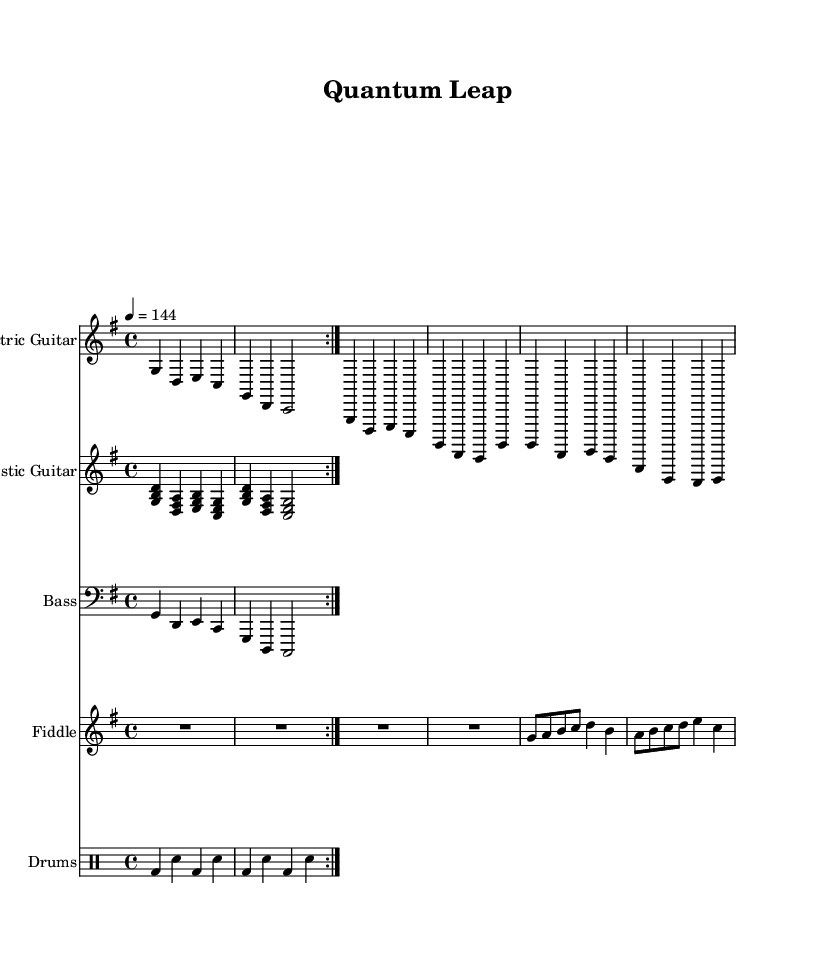What is the key signature of this music? The key signature is G major, which has one sharp (F#).
Answer: G major What is the time signature of this music? The time signature is 4/4, indicating four beats per measure.
Answer: 4/4 What is the tempo marking for this piece? The tempo marking indicates a speed of 144 beats per minute, implying a moderately fast pace.
Answer: 144 How many measures are repeated in the electric guitar part? The electric guitar part has a repeated section of 2 measures, which is indicated by the volta marking.
Answer: 2 measures What instruments are used in this arrangement? The sheet music includes electric guitar, acoustic guitar, bass, fiddle, and drums, showcasing a typical country rock ensemble.
Answer: Electric guitar, acoustic guitar, bass, fiddle, drums What is the dynamic marking in the fiddle section? The dynamic marking is not explicitly indicated in the extracted code, but fiddles typically play with expressiveness and warmth in country-rock. As such, it's common to perform with a lively or bright tone.
Answer: (not explicitly indicated) How does the rhythm in the drums correlate with the overall feel of the piece? The rhythm in the drums is characterized by a repeating bass drum and snare pattern which provides a driving beat that supports the upbeat feel typical of country rock music.
Answer: Driving beat 